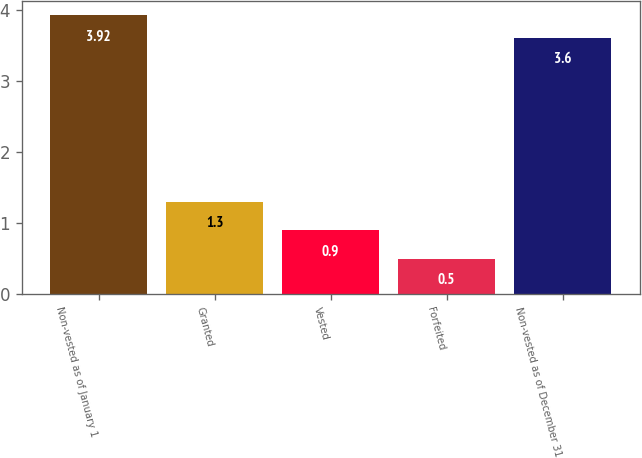<chart> <loc_0><loc_0><loc_500><loc_500><bar_chart><fcel>Non-vested as of January 1<fcel>Granted<fcel>Vested<fcel>Forfeited<fcel>Non-vested as of December 31<nl><fcel>3.92<fcel>1.3<fcel>0.9<fcel>0.5<fcel>3.6<nl></chart> 